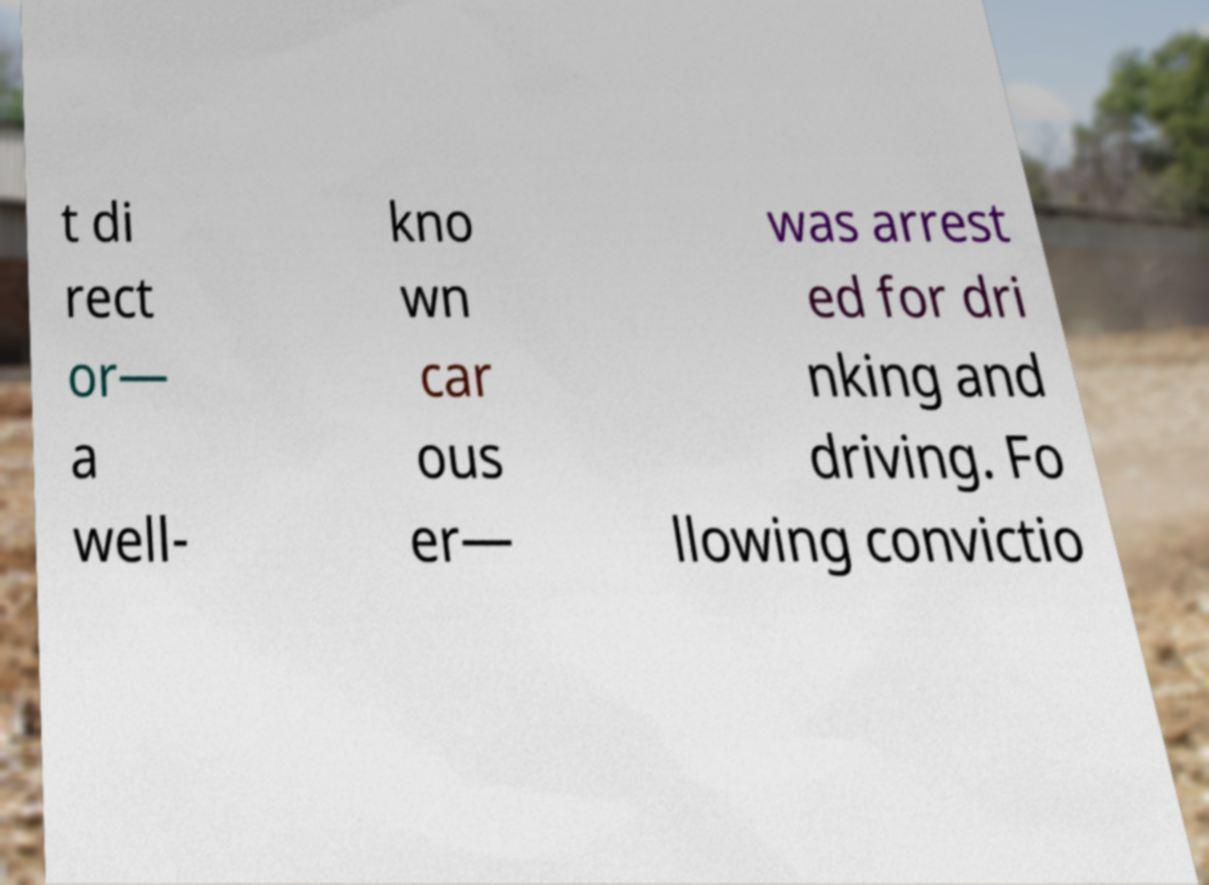What messages or text are displayed in this image? I need them in a readable, typed format. t di rect or— a well- kno wn car ous er— was arrest ed for dri nking and driving. Fo llowing convictio 